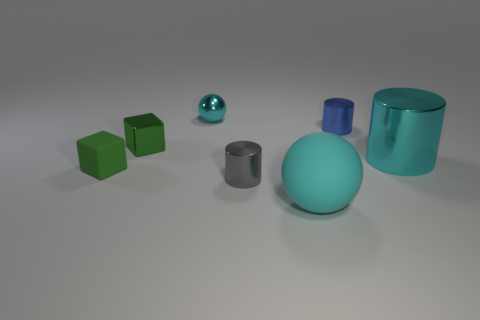Is the large metal thing the same color as the rubber sphere?
Your response must be concise. Yes. There is a thing that is right of the gray metallic thing and in front of the small matte object; what material is it made of?
Your response must be concise. Rubber. What number of gray things have the same size as the cyan shiny ball?
Provide a short and direct response. 1. How many shiny objects are either cylinders or brown spheres?
Make the answer very short. 3. What material is the cyan cylinder?
Provide a succinct answer. Metal. There is a tiny gray metal object; what number of cyan spheres are left of it?
Offer a terse response. 1. Is the material of the big sphere that is left of the cyan metal cylinder the same as the tiny gray thing?
Your answer should be very brief. No. How many small metallic objects are the same shape as the cyan matte object?
Ensure brevity in your answer.  1. What number of big things are either green metallic things or purple rubber spheres?
Provide a succinct answer. 0. There is a metallic cube that is behind the gray object; is its color the same as the small matte block?
Your answer should be very brief. Yes. 